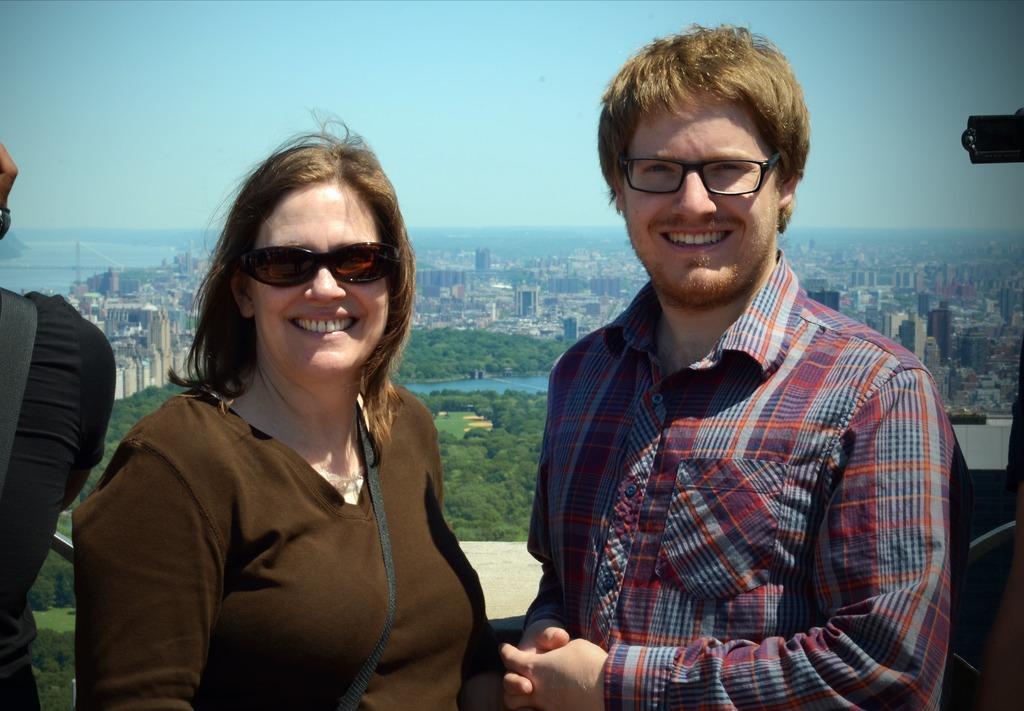How would you summarize this image in a sentence or two? On the background of the picture we can see a clear blue sky. These are the buildings. These are the trees. This is a river. Here we can see a man and a woman who is holding beautiful smile on their faces. They both are wearing specs. AT the left side of the picture we can see one person standing in black dress. 